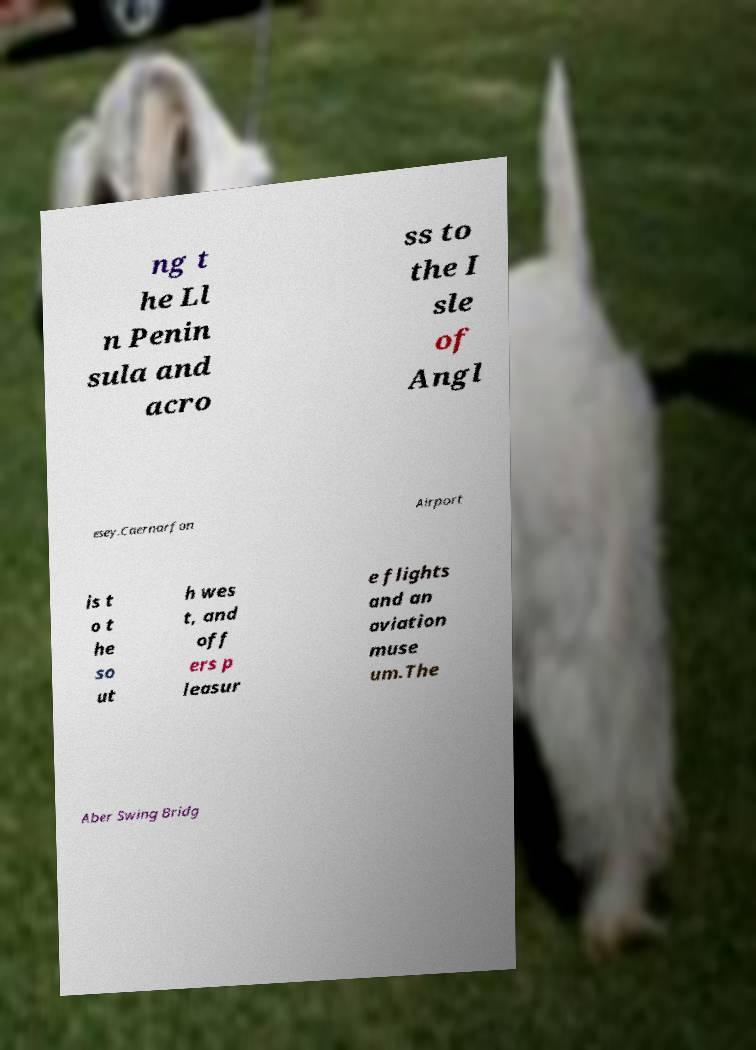Could you assist in decoding the text presented in this image and type it out clearly? ng t he Ll n Penin sula and acro ss to the I sle of Angl esey.Caernarfon Airport is t o t he so ut h wes t, and off ers p leasur e flights and an aviation muse um.The Aber Swing Bridg 